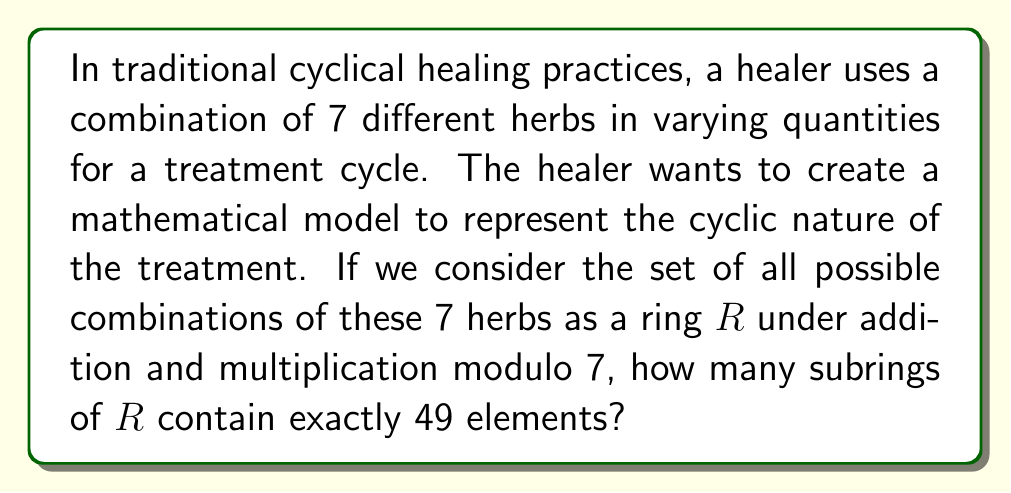Teach me how to tackle this problem. To solve this problem, we need to apply concepts from ring theory:

1) First, we need to understand that the ring $R$ represents all possible combinations of the 7 herbs. Since we're working modulo 7, each herb can have quantities from 0 to 6. This means $R$ has $7^7 = 823,543$ elements.

2) We're looking for subrings with exactly 49 elements. In ring theory, subrings must contain the identity element and be closed under addition and multiplication.

3) In modular arithmetic, a subring with 49 elements would be isomorphic to $\mathbb{Z}_7 \times \mathbb{Z}_7$, which is the direct product of two copies of $\mathbb{Z}_7$.

4) To count how many such subrings exist, we need to find how many ways we can embed $\mathbb{Z}_7 \times \mathbb{Z}_7$ into our larger ring $R$.

5) This is equivalent to finding how many pairs of linearly independent vectors exist in a 7-dimensional vector space over $\mathbb{Z}_7$.

6) The number of ways to choose the first vector (excluding the zero vector) is $7^7 - 1$.

7) For the second vector, we need a vector not in the span of the first vector. There are $7^7 - 7$ such vectors.

8) However, this counts each subring multiple times. We need to divide by the number of ways to generate the same subring, which is $|\text{GL}_2(\mathbb{Z}_7)| = (7^2 - 1)(7^2 - 7) = 2016$.

9) Therefore, the number of subrings with 49 elements is:

   $$\frac{(7^7 - 1)(7^7 - 7)}{2016} = 2,381,400$$

This large number reflects the numerous ways the healer can structure their cyclical healing practice using combinations of the 7 herbs, each with a distinct mathematical pattern.
Answer: 2,381,400 